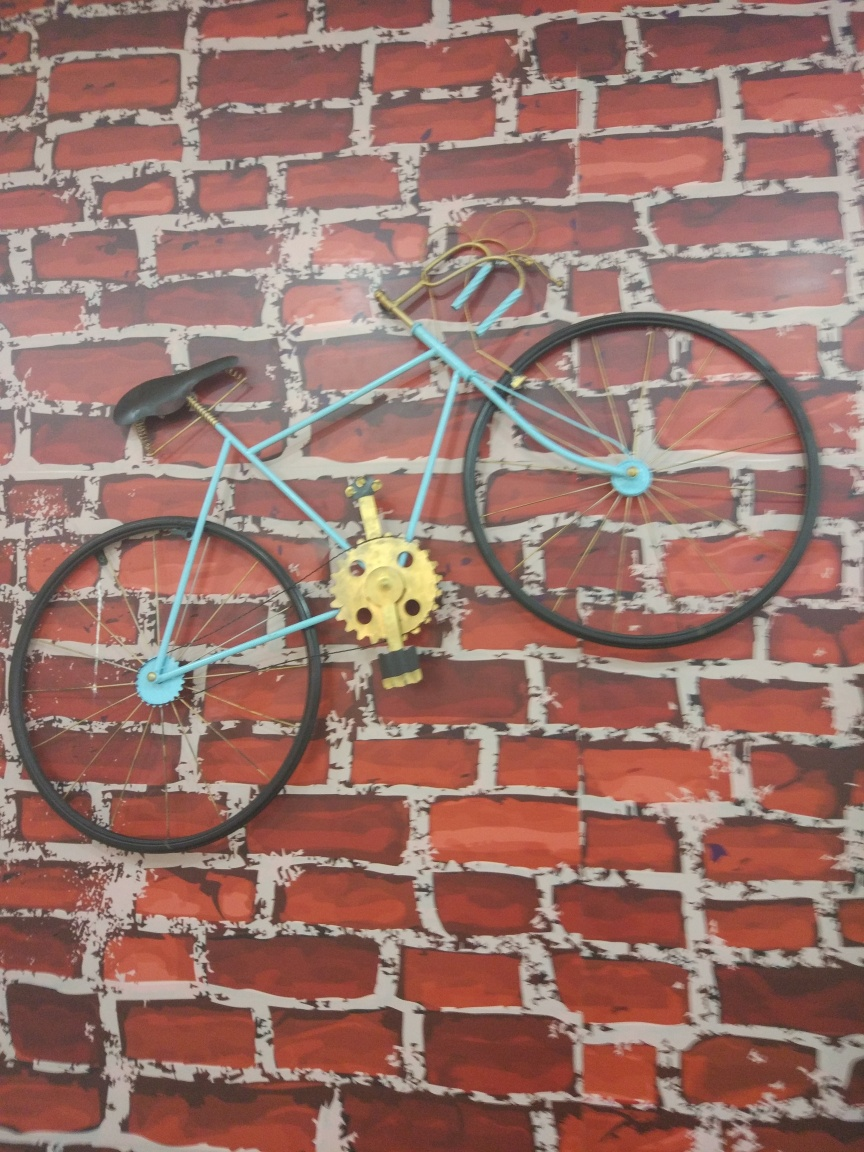What is the style and possible age of this bicycle? The bicycle appears to be styled as a vintage road bike, possibly from the mid-20th century. This is suggested by the thin frame, the shape of the handlebars, and the type of seat. However, the vivid color choice of blue and the fact that it is mounted on a wall also suggests it may be a modern decorative piece inspired by vintage designs, rather than an authentic old bicycle ready for use. 